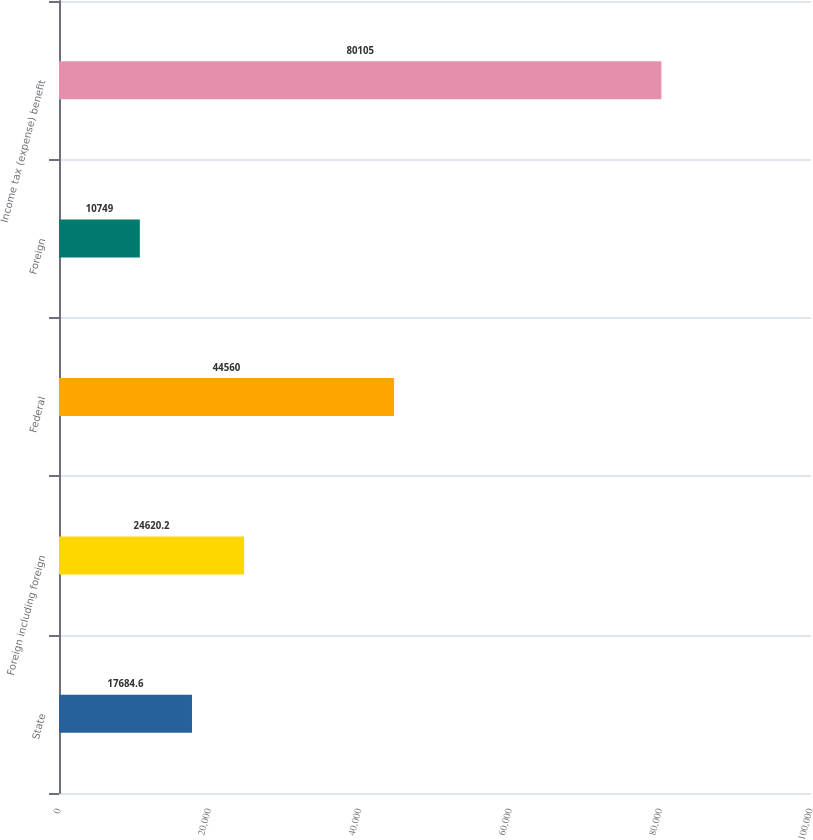Convert chart to OTSL. <chart><loc_0><loc_0><loc_500><loc_500><bar_chart><fcel>State<fcel>Foreign including foreign<fcel>Federal<fcel>Foreign<fcel>Income tax (expense) benefit<nl><fcel>17684.6<fcel>24620.2<fcel>44560<fcel>10749<fcel>80105<nl></chart> 